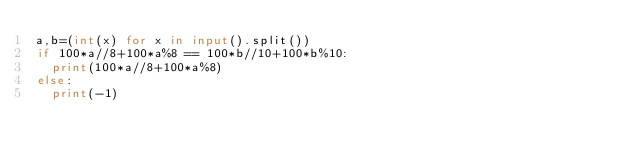<code> <loc_0><loc_0><loc_500><loc_500><_Python_>a,b=(int(x) for x in input().split())
if 100*a//8+100*a%8 == 100*b//10+100*b%10:
  print(100*a//8+100*a%8)
else:
  print(-1)</code> 